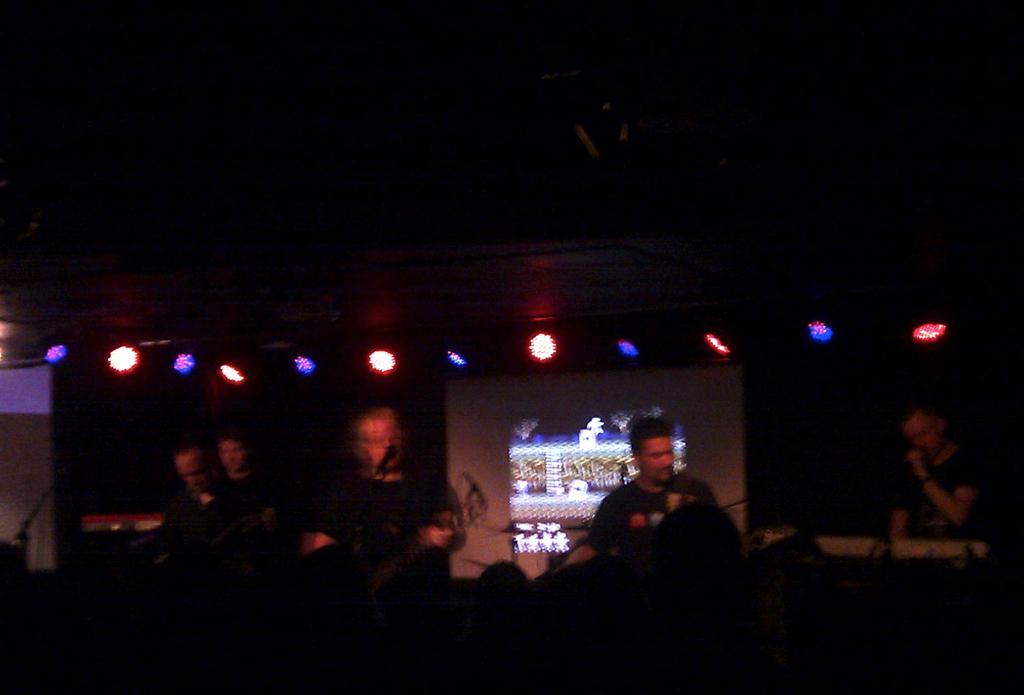Describe this image in one or two sentences. In this image we can able to see few persons playing musical, and behind them there are some lights, and also there is a screen behind them, and one person is singing. 